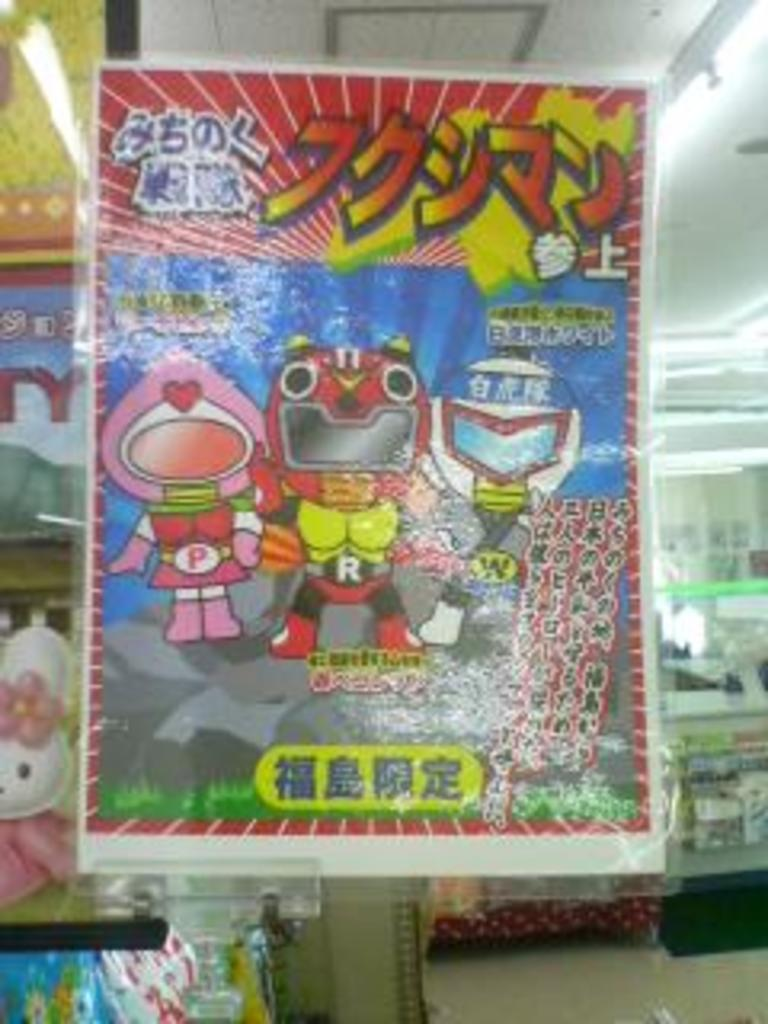What type of poster is in the image? There is a poster with animation pictures in the image. What else can be seen on the poster besides the animation pictures? There is text written on the poster. What can be seen in the background of the image? There are toys visible in the background of the image. What type of lighting is present in the image? There are lights on the ceiling in the image. How does the poster make a decision about which animation to display? The poster does not make decisions; it is an inanimate object. The animation pictures are printed or displayed on the poster and do not change or make decisions. 